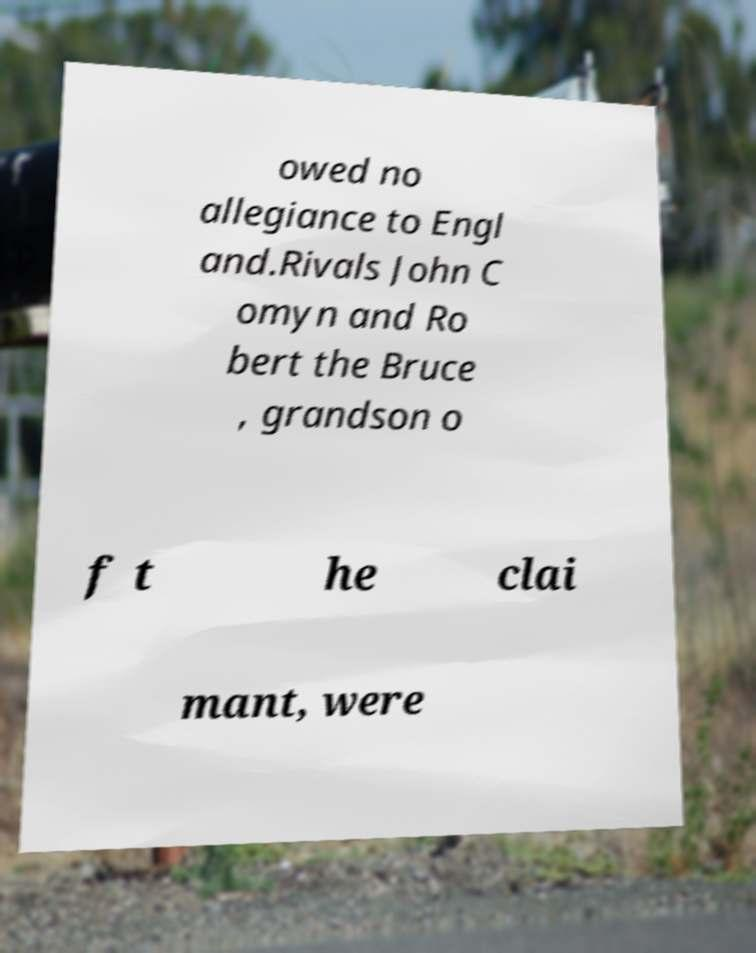Please read and relay the text visible in this image. What does it say? owed no allegiance to Engl and.Rivals John C omyn and Ro bert the Bruce , grandson o f t he clai mant, were 